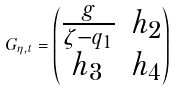<formula> <loc_0><loc_0><loc_500><loc_500>G _ { \eta , t } = \begin{pmatrix} \frac { g } { \zeta - q _ { 1 } } & h _ { 2 } \\ h _ { 3 } & h _ { 4 } \end{pmatrix}</formula> 